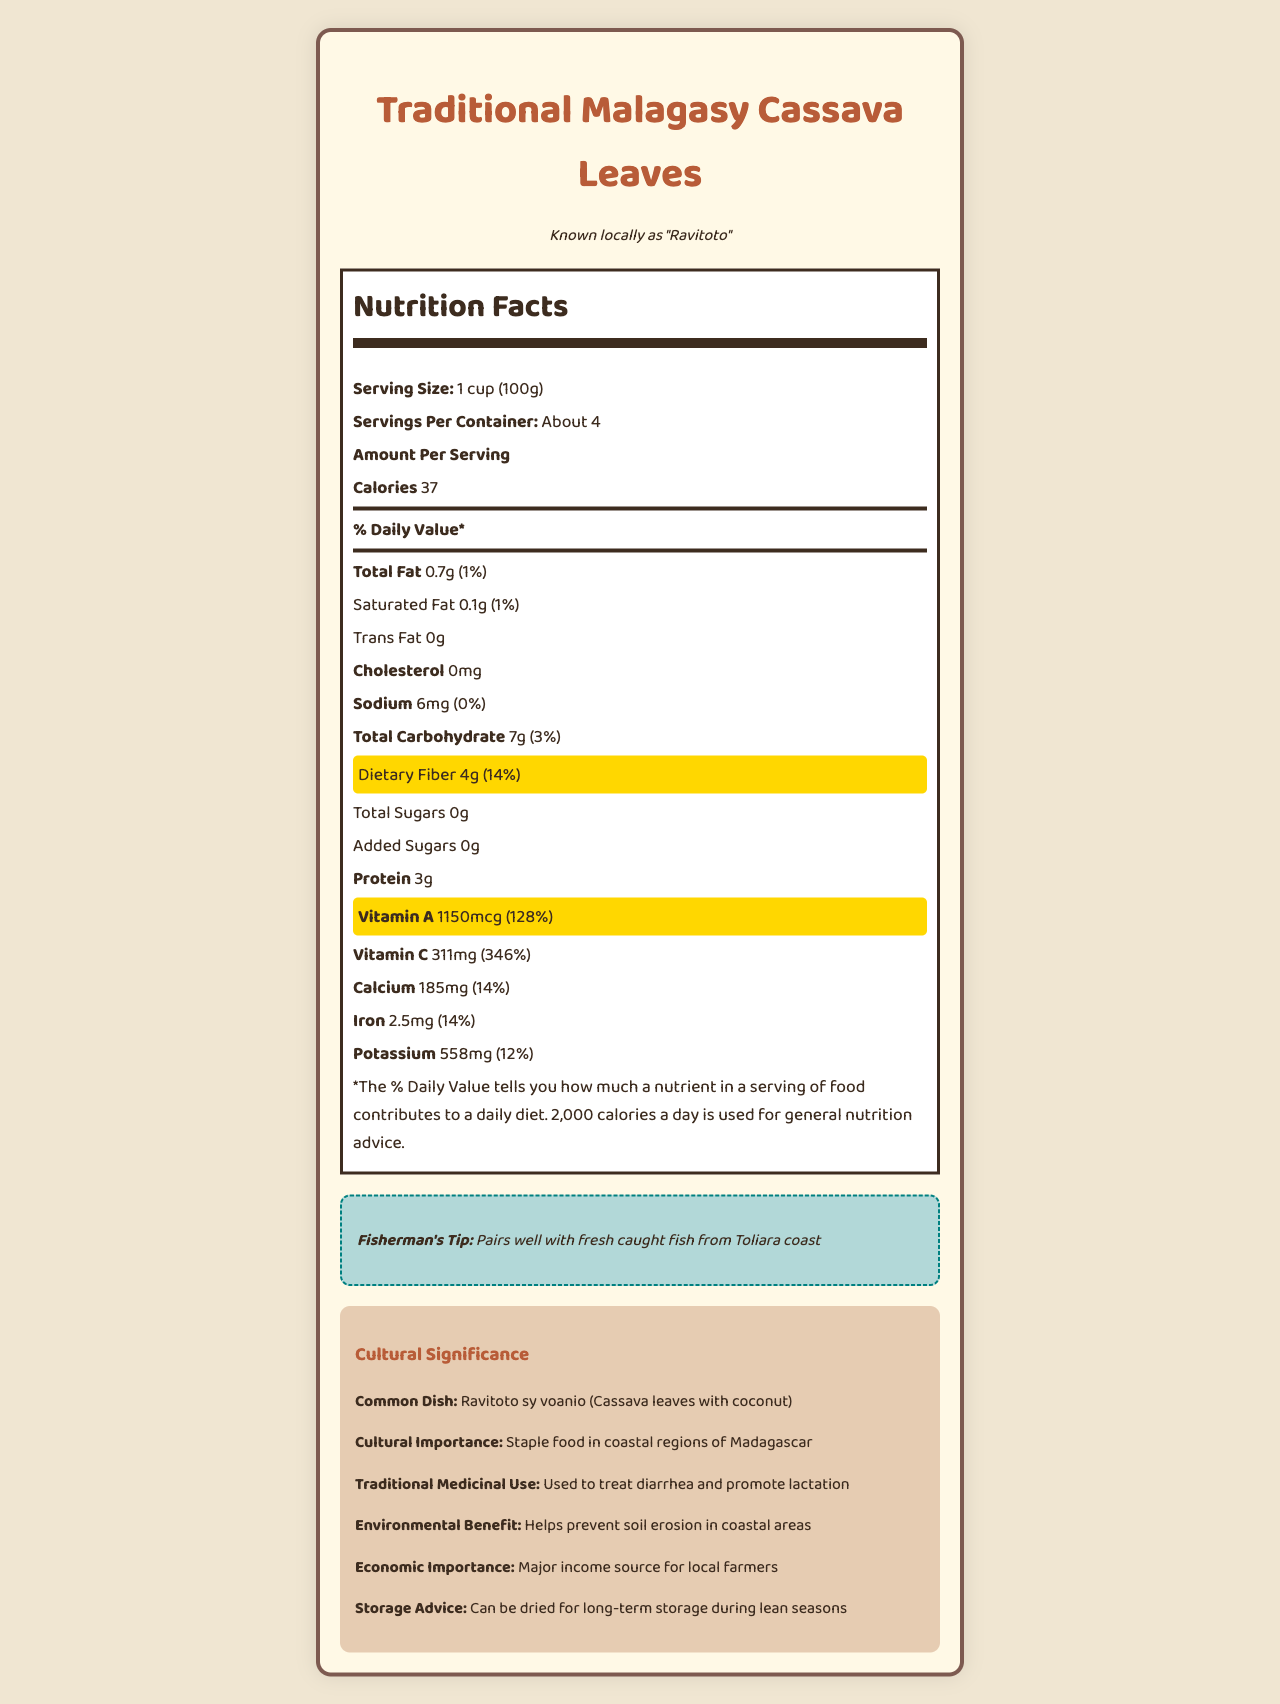what is the serving size for traditional Malagasy cassava leaves? The serving size is clearly mentioned as "1 cup (100g)" in the nutrition facts label.
Answer: 1 cup (100g) How many grams of dietary fiber are in one serving? The label states that dietary fiber per serving is 4g.
Answer: 4g What is the percentage of Daily Value for vitamin A per serving? The label shows that vitamin A contributes 128% to the Daily Value per serving.
Answer: 128% What is the common dish made with ravitoto? The document mentions that a common dish made with cassava leaves is "Ravitoto sy voanio (Cassava leaves with coconut)".
Answer: Ravitoto sy voanio (Cassava leaves with coconut) How many servings are there per container? The document states there are about 4 servings per container.
Answer: About 4 Which nutrient has the highest percentage of Daily Value? A. Calcium B. Vitamin A C. Protein The nutrition label indicates that vitamin A has a Daily Value of 128%, which is higher than the other nutrients listed.
Answer: B. Vitamin A Which of the following is not found in traditional Malagasy cassava leaves? A. Total Sugars B. Cholesterol C. Protein The label indicates that total sugars are 0g. Both cholesterol and protein are found in the nutritional content.
Answer: A. Total Sugars Are traditional Malagasy cassava leaves a good source of fiber? The dietary fiber in cassava leaves provides 14% of the Daily Value, indicating it is a good source of fiber.
Answer: Yes Summarize the nutritional benefits of traditional Malagasy cassava leaves. The leaves have high vitamin A and dietary fiber content, with additional benefits such as protein and vitamin C. They are culturally significant and economically important in Madagascar, making them a staple food in coastal regions.
Answer: Traditional Malagasy cassava leaves, known locally as ravitoto, are rich in vitamin A and dietary fiber. Per serving, they provide 128% of the Daily Value for vitamin A and 14% for dietary fiber. They are also a good source of protein and vitamin C, contributing to 14% and 346% of their Daily Values respectively. They have minimal fat and sodium content. Furthermore, they hold cultural and economic significance in Madagascar. What is the preparation method for traditional Malagasy cassava leaves? The label states that the traditional preparation method for cassava leaves is boiling and pounding them.
Answer: Boiled and pounded During which season can cassava leaves be harvested locally? The document indicates that cassava leaves can be harvested year-round.
Answer: Year-round What is the exact amount of calcium in one serving? The nutritional label lists calcium content as 185mg per serving.
Answer: 185mg Can the amount of protein in one serving of cassava leaves be determined by the document? The document states that there are 3g of protein per serving.
Answer: Yes What is the economic sensitivity of cassava leaves to drought? The document mentions that cassava leaves are a drought-resistant crop but doesn't provide detailed information regarding economic impacts.
Answer: Not enough information 